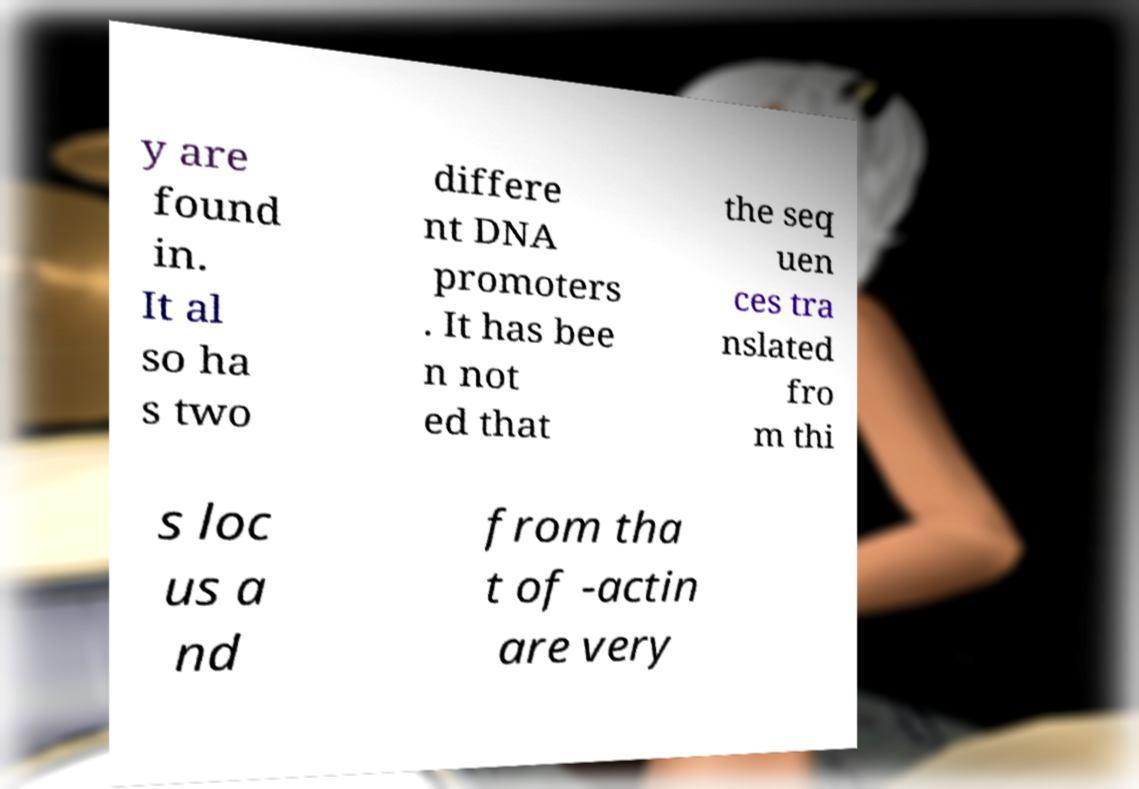Can you read and provide the text displayed in the image?This photo seems to have some interesting text. Can you extract and type it out for me? y are found in. It al so ha s two differe nt DNA promoters . It has bee n not ed that the seq uen ces tra nslated fro m thi s loc us a nd from tha t of -actin are very 